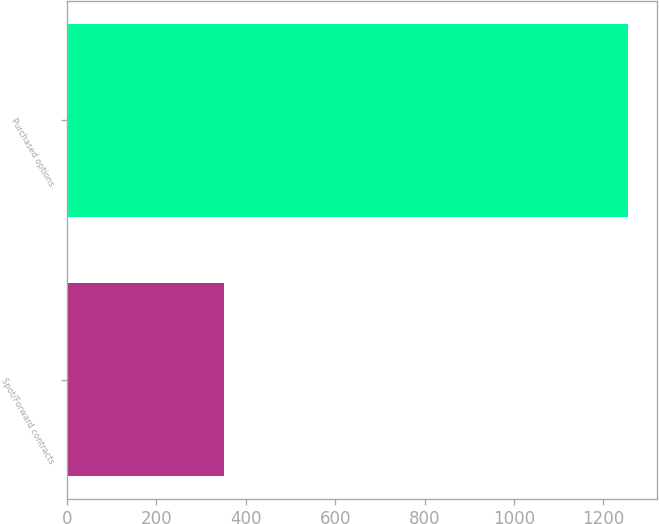Convert chart. <chart><loc_0><loc_0><loc_500><loc_500><bar_chart><fcel>Spot/Forward contracts<fcel>Purchased options<nl><fcel>351<fcel>1256<nl></chart> 